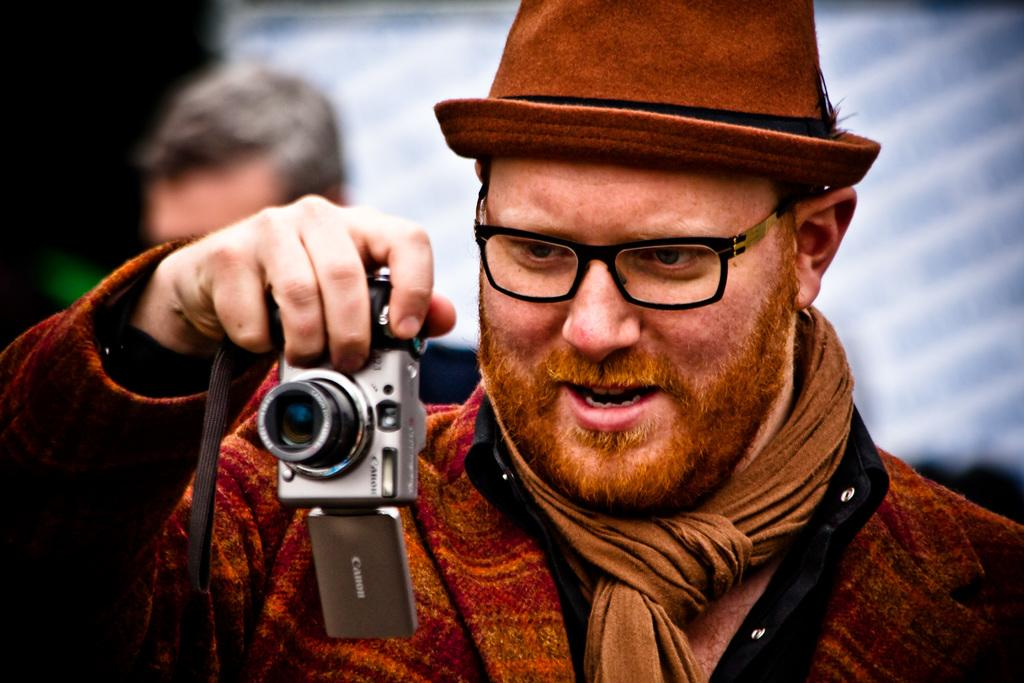Who is the main subject in the image? There is a man in the image. What is the man holding in the image? The man is holding a camera. What accessories is the man wearing in the image? The man is wearing glasses (specs) and a hat. What type of wool is the man using to take a recess in the image? There is no wool or recess present in the image. The man is holding a camera and wearing glasses and a hat. 